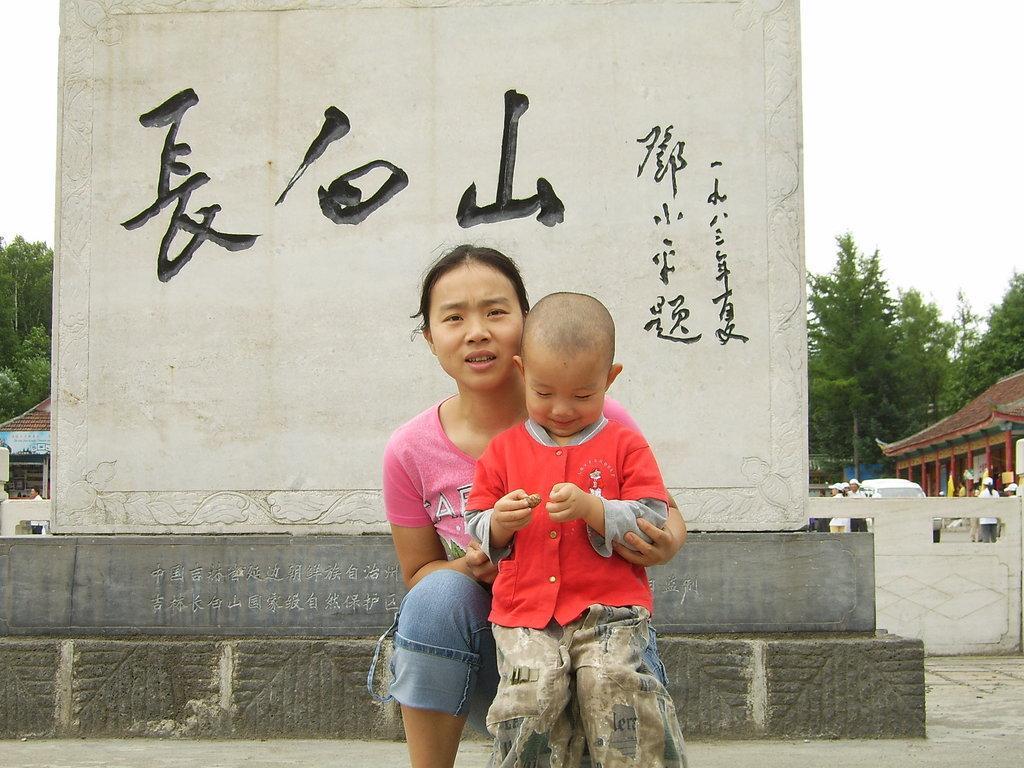In one or two sentences, can you explain what this image depicts? In this image we can see a woman wearing pink T-shirt and a child wearing red shirt are standing here. In the background, we can see the wall on which we can see some text, we can see houses, we can see people, vehicles moving on the road, trees and the sky. 